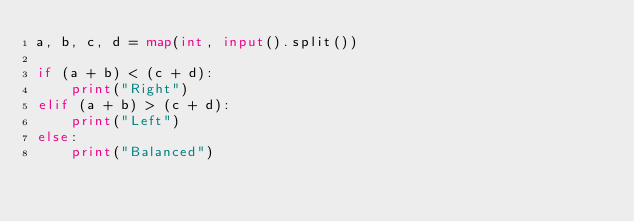<code> <loc_0><loc_0><loc_500><loc_500><_Python_>a, b, c, d = map(int, input().split())

if (a + b) < (c + d):
    print("Right")
elif (a + b) > (c + d):
    print("Left")
else:
    print("Balanced")
</code> 